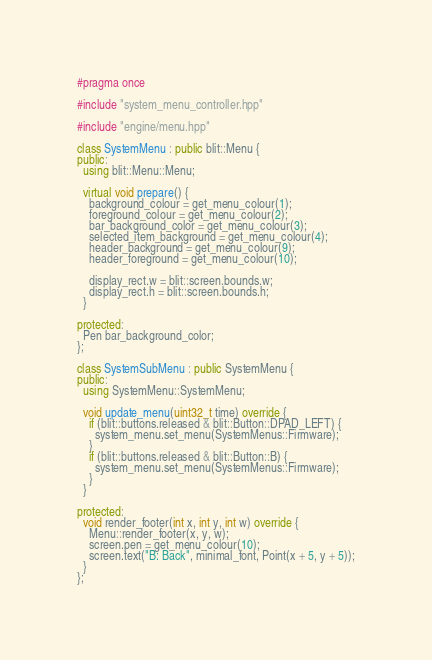<code> <loc_0><loc_0><loc_500><loc_500><_C++_>#pragma once

#include "system_menu_controller.hpp"

#include "engine/menu.hpp"

class SystemMenu : public blit::Menu {
public:
  using blit::Menu::Menu;

  virtual void prepare() {
    background_colour = get_menu_colour(1);
    foreground_colour = get_menu_colour(2);
    bar_background_color = get_menu_colour(3);
    selected_item_background = get_menu_colour(4);
    header_background = get_menu_colour(9);
    header_foreground = get_menu_colour(10);

    display_rect.w = blit::screen.bounds.w;
    display_rect.h = blit::screen.bounds.h;
  }

protected:
  Pen bar_background_color;
};

class SystemSubMenu : public SystemMenu {
public:
  using SystemMenu::SystemMenu;

  void update_menu(uint32_t time) override {
    if (blit::buttons.released & blit::Button::DPAD_LEFT) {
      system_menu.set_menu(SystemMenus::Firmware);
    }
    if (blit::buttons.released & blit::Button::B) {
      system_menu.set_menu(SystemMenus::Firmware);
    }
  }

protected:
  void render_footer(int x, int y, int w) override {
    Menu::render_footer(x, y, w);
    screen.pen = get_menu_colour(10);
    screen.text("B: Back", minimal_font, Point(x + 5, y + 5));
  }
};
</code> 